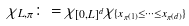Convert formula to latex. <formula><loc_0><loc_0><loc_500><loc_500>\chi _ { L , \pi } \colon = \chi _ { [ 0 , L ] ^ { d } } \chi _ { \{ x _ { \pi ( 1 ) } \leq \dots \leq x _ { \pi ( d ) } \} }</formula> 